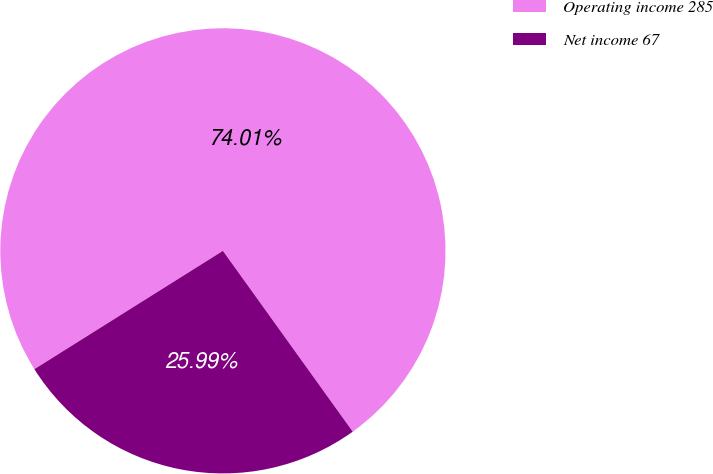<chart> <loc_0><loc_0><loc_500><loc_500><pie_chart><fcel>Operating income 285<fcel>Net income 67<nl><fcel>74.01%<fcel>25.99%<nl></chart> 